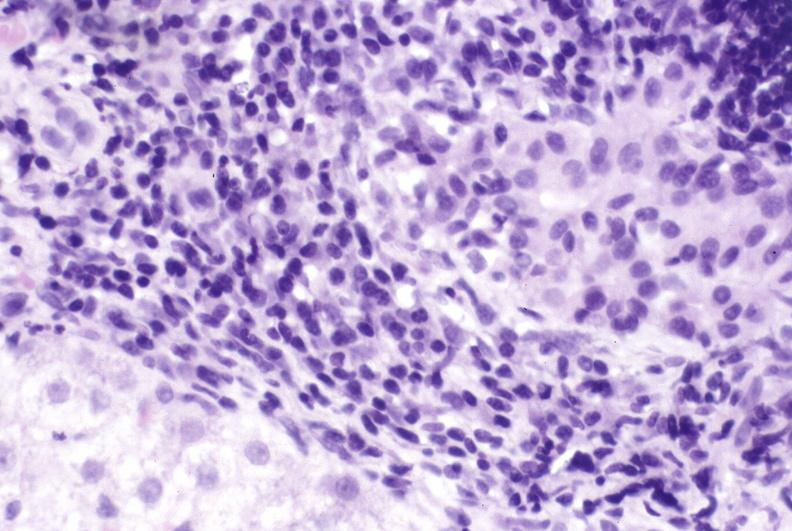does this image show primary biliary cirrhosis?
Answer the question using a single word or phrase. Yes 